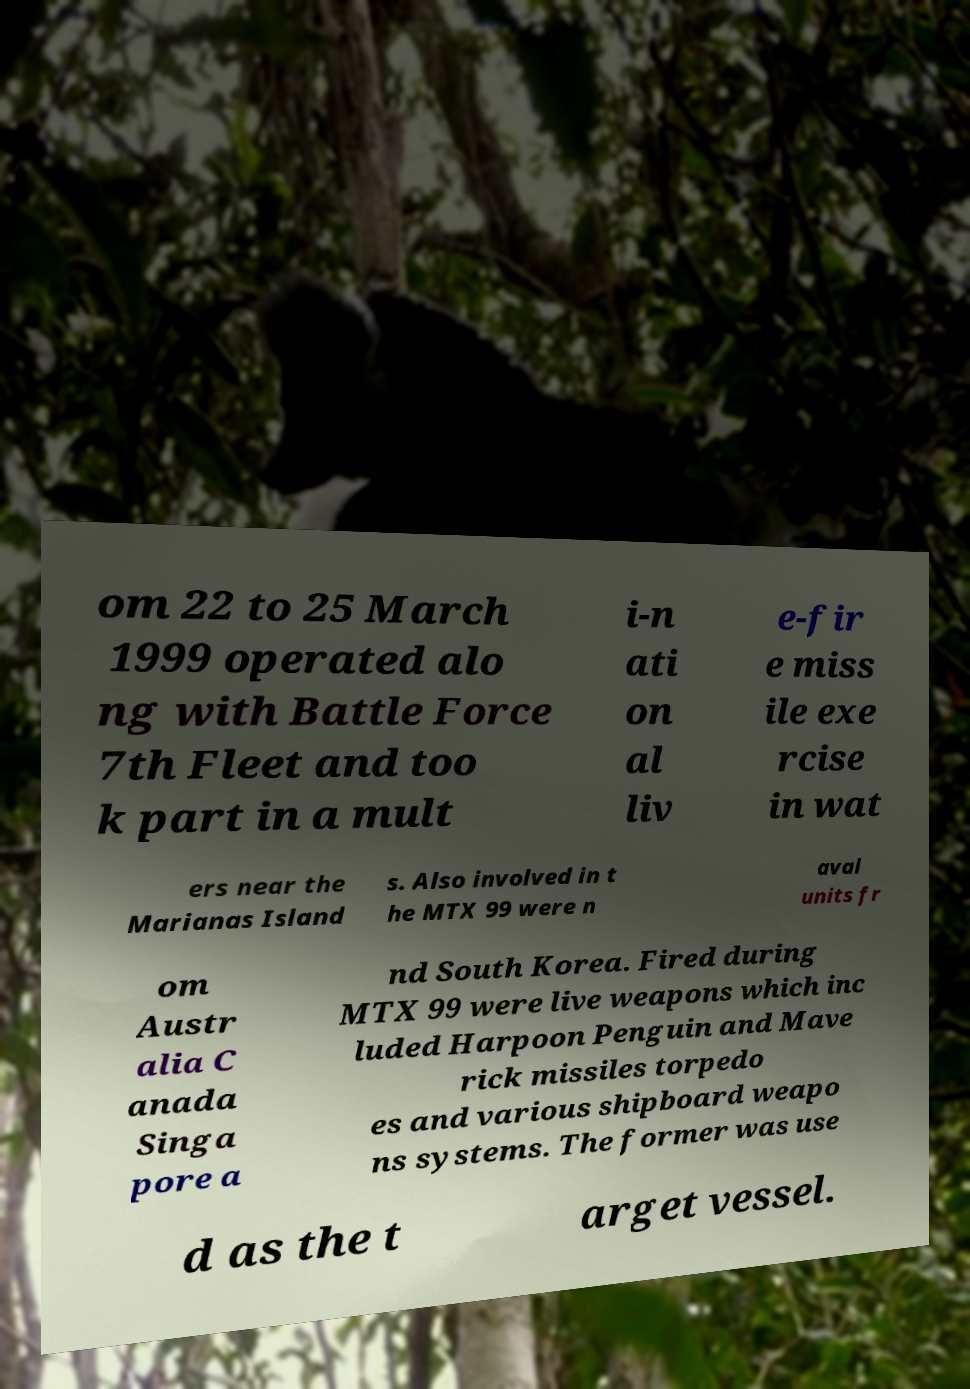Please identify and transcribe the text found in this image. om 22 to 25 March 1999 operated alo ng with Battle Force 7th Fleet and too k part in a mult i-n ati on al liv e-fir e miss ile exe rcise in wat ers near the Marianas Island s. Also involved in t he MTX 99 were n aval units fr om Austr alia C anada Singa pore a nd South Korea. Fired during MTX 99 were live weapons which inc luded Harpoon Penguin and Mave rick missiles torpedo es and various shipboard weapo ns systems. The former was use d as the t arget vessel. 